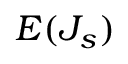Convert formula to latex. <formula><loc_0><loc_0><loc_500><loc_500>E ( J _ { s } )</formula> 